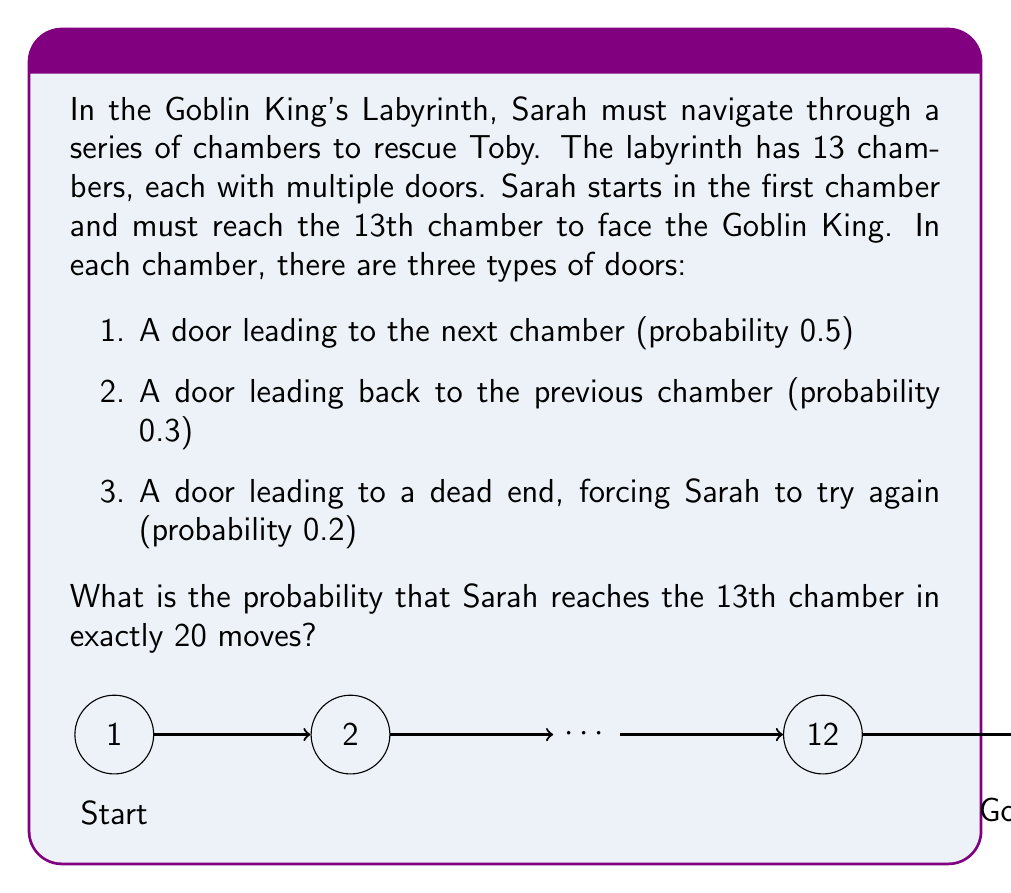Show me your answer to this math problem. To solve this problem, we can use the concept of negative binomial distribution. Here's a step-by-step explanation:

1) Sarah needs to make 12 forward moves to reach the 13th chamber.

2) Let $X$ be the number of moves needed to reach the 13th chamber. We want $P(X = 20)$.

3) This follows a negative binomial distribution with parameters $r = 12$ (number of successes needed) and $p = 0.5$ (probability of success on each trial).

4) The probability mass function for the negative binomial distribution is:

   $$P(X = k) = \binom{k-1}{r-1} p^r (1-p)^{k-r}$$

5) In our case, $k = 20$, $r = 12$, and $p = 0.5$. Let's substitute these values:

   $$P(X = 20) = \binom{19}{11} (0.5)^{12} (0.5)^8$$

6) Calculate the binomial coefficient:

   $$\binom{19}{11} = \frac{19!}{11!(19-11)!} = 75582$$

7) Now, let's calculate the full probability:

   $$P(X = 20) = 75582 \cdot (0.5)^{12} \cdot (0.5)^8 = 75582 \cdot (0.5)^{20} = 75582 \cdot \frac{1}{1048576} \approx 0.0721$$

Therefore, the probability that Sarah reaches the 13th chamber in exactly 20 moves is approximately 0.0721 or 7.21%.
Answer: $\frac{75582}{1048576} \approx 0.0721$ 